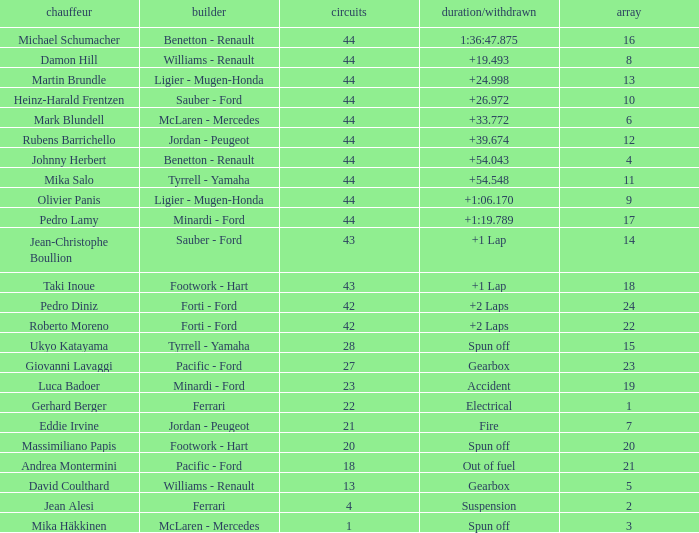Who built the car that ran out of fuel before 28 laps? Pacific - Ford. 